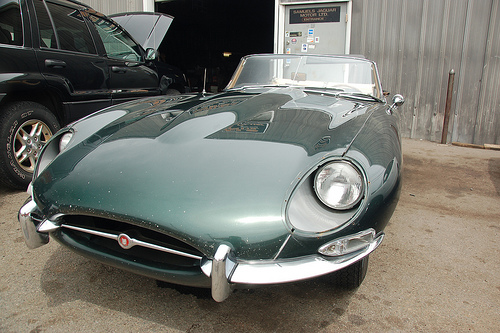<image>
Is there a car in front of the door? Yes. The car is positioned in front of the door, appearing closer to the camera viewpoint. 